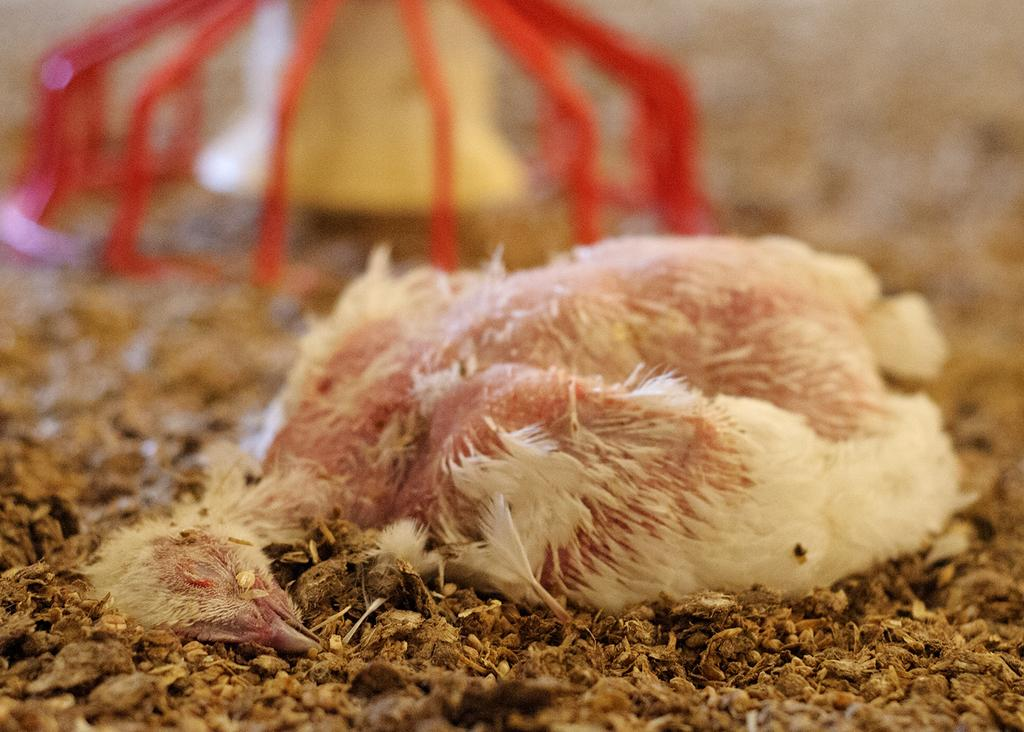What animal can be seen on the ground in the image? There is a bird on the ground in the image. How would you describe the background of the image? The background of the image is blurry. Can you identify any objects in the background of the image? There is an object visible in the background of the image. What type of scarf is the bird wearing in the image? There is no scarf present in the image, and the bird is not wearing any clothing. 